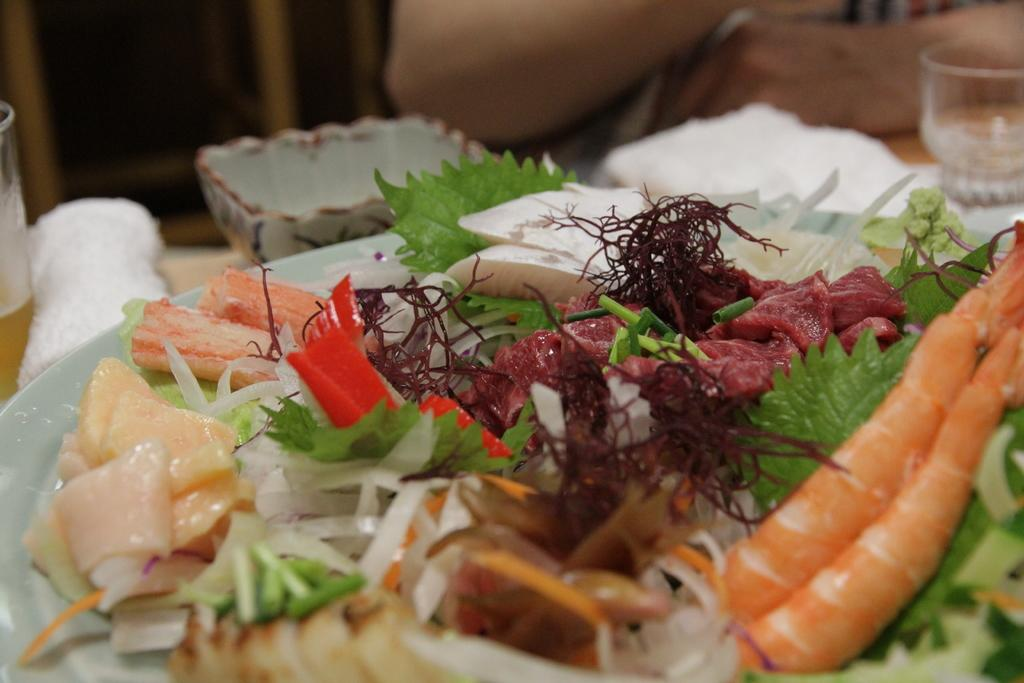What is on the plate that is visible in the image? There is food on a plate in the image. What objects can be seen in the background of the image? There are glasses, papers, and a bowl in the background of the image. Who is present in the image? There is a person in the image. What is the setting of the image? There is a wall in the image. What is the price of the boot in the image? There is no boot present in the image, so it is not possible to determine its price. 